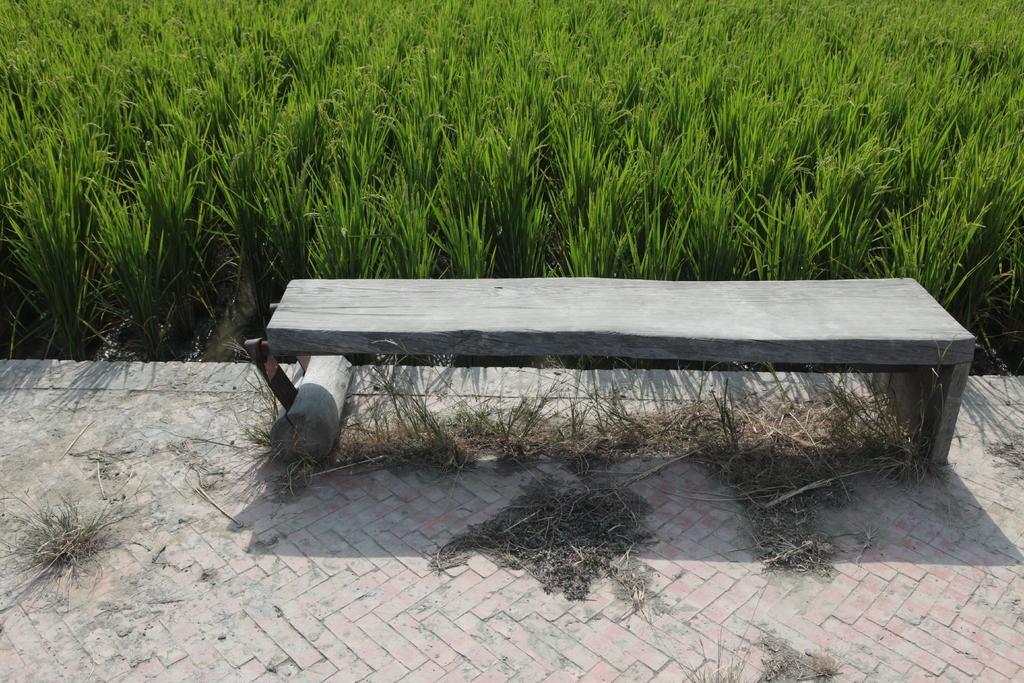In one or two sentences, can you explain what this image depicts? In this image here there is a bench. This is the floor. Few dusts are there. In the background there are plants. 